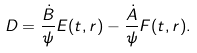<formula> <loc_0><loc_0><loc_500><loc_500>D = \frac { \dot { B } } { \psi } E ( t , r ) - \frac { \dot { A } } { \psi } F ( t , r ) .</formula> 